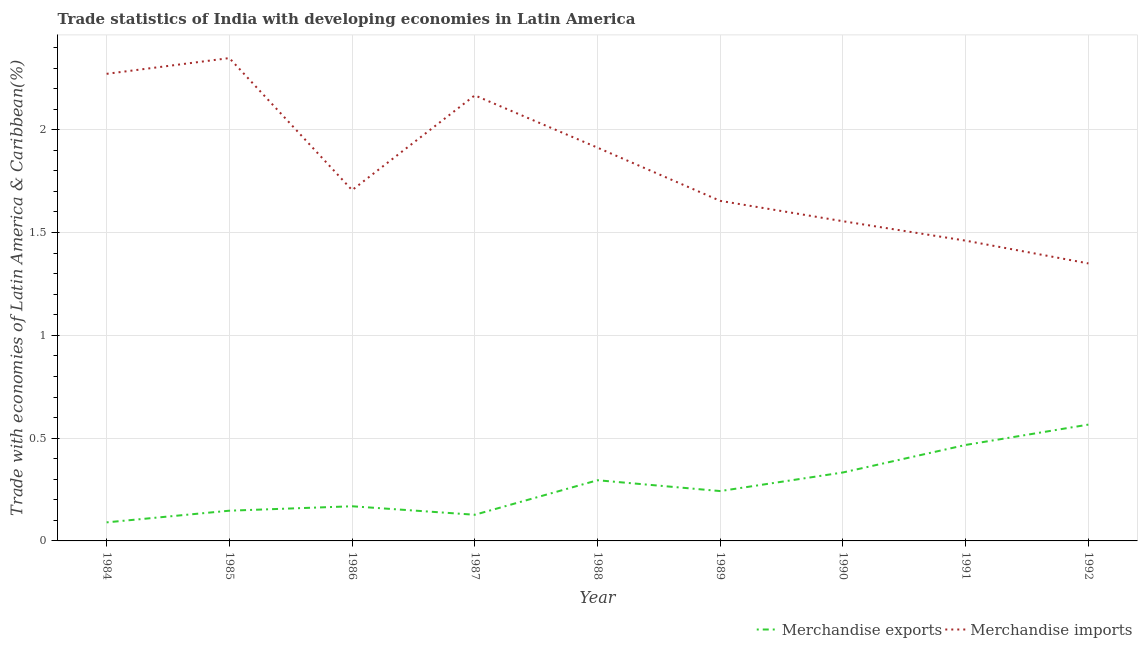Does the line corresponding to merchandise exports intersect with the line corresponding to merchandise imports?
Your answer should be compact. No. Is the number of lines equal to the number of legend labels?
Provide a short and direct response. Yes. What is the merchandise exports in 1989?
Provide a succinct answer. 0.24. Across all years, what is the maximum merchandise imports?
Your response must be concise. 2.35. Across all years, what is the minimum merchandise exports?
Your answer should be very brief. 0.09. In which year was the merchandise imports minimum?
Ensure brevity in your answer.  1992. What is the total merchandise imports in the graph?
Provide a short and direct response. 16.43. What is the difference between the merchandise exports in 1989 and that in 1992?
Your answer should be compact. -0.32. What is the difference between the merchandise imports in 1985 and the merchandise exports in 1990?
Your answer should be very brief. 2.02. What is the average merchandise imports per year?
Provide a succinct answer. 1.83. In the year 1989, what is the difference between the merchandise imports and merchandise exports?
Provide a short and direct response. 1.41. What is the ratio of the merchandise imports in 1984 to that in 1987?
Provide a succinct answer. 1.05. Is the difference between the merchandise imports in 1986 and 1988 greater than the difference between the merchandise exports in 1986 and 1988?
Provide a succinct answer. No. What is the difference between the highest and the second highest merchandise exports?
Offer a very short reply. 0.1. What is the difference between the highest and the lowest merchandise exports?
Offer a very short reply. 0.48. Is the sum of the merchandise imports in 1987 and 1991 greater than the maximum merchandise exports across all years?
Your answer should be very brief. Yes. Does the merchandise imports monotonically increase over the years?
Ensure brevity in your answer.  No. How many lines are there?
Provide a short and direct response. 2. How many years are there in the graph?
Ensure brevity in your answer.  9. What is the difference between two consecutive major ticks on the Y-axis?
Your response must be concise. 0.5. Where does the legend appear in the graph?
Provide a short and direct response. Bottom right. What is the title of the graph?
Your response must be concise. Trade statistics of India with developing economies in Latin America. Does "Rural" appear as one of the legend labels in the graph?
Your response must be concise. No. What is the label or title of the X-axis?
Your answer should be compact. Year. What is the label or title of the Y-axis?
Make the answer very short. Trade with economies of Latin America & Caribbean(%). What is the Trade with economies of Latin America & Caribbean(%) of Merchandise exports in 1984?
Keep it short and to the point. 0.09. What is the Trade with economies of Latin America & Caribbean(%) of Merchandise imports in 1984?
Give a very brief answer. 2.27. What is the Trade with economies of Latin America & Caribbean(%) in Merchandise exports in 1985?
Your answer should be very brief. 0.15. What is the Trade with economies of Latin America & Caribbean(%) in Merchandise imports in 1985?
Your answer should be compact. 2.35. What is the Trade with economies of Latin America & Caribbean(%) in Merchandise exports in 1986?
Ensure brevity in your answer.  0.17. What is the Trade with economies of Latin America & Caribbean(%) in Merchandise imports in 1986?
Give a very brief answer. 1.71. What is the Trade with economies of Latin America & Caribbean(%) of Merchandise exports in 1987?
Make the answer very short. 0.13. What is the Trade with economies of Latin America & Caribbean(%) in Merchandise imports in 1987?
Give a very brief answer. 2.17. What is the Trade with economies of Latin America & Caribbean(%) in Merchandise exports in 1988?
Provide a short and direct response. 0.3. What is the Trade with economies of Latin America & Caribbean(%) in Merchandise imports in 1988?
Your answer should be compact. 1.91. What is the Trade with economies of Latin America & Caribbean(%) in Merchandise exports in 1989?
Your response must be concise. 0.24. What is the Trade with economies of Latin America & Caribbean(%) of Merchandise imports in 1989?
Offer a very short reply. 1.65. What is the Trade with economies of Latin America & Caribbean(%) of Merchandise exports in 1990?
Your answer should be compact. 0.33. What is the Trade with economies of Latin America & Caribbean(%) in Merchandise imports in 1990?
Your response must be concise. 1.56. What is the Trade with economies of Latin America & Caribbean(%) in Merchandise exports in 1991?
Make the answer very short. 0.47. What is the Trade with economies of Latin America & Caribbean(%) of Merchandise imports in 1991?
Keep it short and to the point. 1.46. What is the Trade with economies of Latin America & Caribbean(%) of Merchandise exports in 1992?
Offer a very short reply. 0.57. What is the Trade with economies of Latin America & Caribbean(%) in Merchandise imports in 1992?
Your response must be concise. 1.35. Across all years, what is the maximum Trade with economies of Latin America & Caribbean(%) in Merchandise exports?
Provide a short and direct response. 0.57. Across all years, what is the maximum Trade with economies of Latin America & Caribbean(%) in Merchandise imports?
Provide a succinct answer. 2.35. Across all years, what is the minimum Trade with economies of Latin America & Caribbean(%) of Merchandise exports?
Give a very brief answer. 0.09. Across all years, what is the minimum Trade with economies of Latin America & Caribbean(%) in Merchandise imports?
Your answer should be very brief. 1.35. What is the total Trade with economies of Latin America & Caribbean(%) of Merchandise exports in the graph?
Provide a short and direct response. 2.44. What is the total Trade with economies of Latin America & Caribbean(%) in Merchandise imports in the graph?
Your answer should be very brief. 16.43. What is the difference between the Trade with economies of Latin America & Caribbean(%) in Merchandise exports in 1984 and that in 1985?
Offer a very short reply. -0.06. What is the difference between the Trade with economies of Latin America & Caribbean(%) in Merchandise imports in 1984 and that in 1985?
Offer a very short reply. -0.08. What is the difference between the Trade with economies of Latin America & Caribbean(%) of Merchandise exports in 1984 and that in 1986?
Provide a succinct answer. -0.08. What is the difference between the Trade with economies of Latin America & Caribbean(%) in Merchandise imports in 1984 and that in 1986?
Give a very brief answer. 0.57. What is the difference between the Trade with economies of Latin America & Caribbean(%) in Merchandise exports in 1984 and that in 1987?
Give a very brief answer. -0.04. What is the difference between the Trade with economies of Latin America & Caribbean(%) in Merchandise imports in 1984 and that in 1987?
Offer a terse response. 0.1. What is the difference between the Trade with economies of Latin America & Caribbean(%) of Merchandise exports in 1984 and that in 1988?
Provide a short and direct response. -0.2. What is the difference between the Trade with economies of Latin America & Caribbean(%) of Merchandise imports in 1984 and that in 1988?
Offer a terse response. 0.36. What is the difference between the Trade with economies of Latin America & Caribbean(%) of Merchandise exports in 1984 and that in 1989?
Give a very brief answer. -0.15. What is the difference between the Trade with economies of Latin America & Caribbean(%) of Merchandise imports in 1984 and that in 1989?
Offer a terse response. 0.62. What is the difference between the Trade with economies of Latin America & Caribbean(%) of Merchandise exports in 1984 and that in 1990?
Your response must be concise. -0.24. What is the difference between the Trade with economies of Latin America & Caribbean(%) of Merchandise imports in 1984 and that in 1990?
Provide a succinct answer. 0.72. What is the difference between the Trade with economies of Latin America & Caribbean(%) of Merchandise exports in 1984 and that in 1991?
Keep it short and to the point. -0.38. What is the difference between the Trade with economies of Latin America & Caribbean(%) in Merchandise imports in 1984 and that in 1991?
Your response must be concise. 0.81. What is the difference between the Trade with economies of Latin America & Caribbean(%) in Merchandise exports in 1984 and that in 1992?
Provide a short and direct response. -0.48. What is the difference between the Trade with economies of Latin America & Caribbean(%) in Merchandise imports in 1984 and that in 1992?
Provide a short and direct response. 0.92. What is the difference between the Trade with economies of Latin America & Caribbean(%) of Merchandise exports in 1985 and that in 1986?
Your answer should be compact. -0.02. What is the difference between the Trade with economies of Latin America & Caribbean(%) in Merchandise imports in 1985 and that in 1986?
Keep it short and to the point. 0.64. What is the difference between the Trade with economies of Latin America & Caribbean(%) of Merchandise exports in 1985 and that in 1987?
Make the answer very short. 0.02. What is the difference between the Trade with economies of Latin America & Caribbean(%) in Merchandise imports in 1985 and that in 1987?
Provide a short and direct response. 0.18. What is the difference between the Trade with economies of Latin America & Caribbean(%) in Merchandise exports in 1985 and that in 1988?
Make the answer very short. -0.15. What is the difference between the Trade with economies of Latin America & Caribbean(%) in Merchandise imports in 1985 and that in 1988?
Your response must be concise. 0.44. What is the difference between the Trade with economies of Latin America & Caribbean(%) in Merchandise exports in 1985 and that in 1989?
Provide a short and direct response. -0.1. What is the difference between the Trade with economies of Latin America & Caribbean(%) in Merchandise imports in 1985 and that in 1989?
Provide a succinct answer. 0.69. What is the difference between the Trade with economies of Latin America & Caribbean(%) of Merchandise exports in 1985 and that in 1990?
Your answer should be very brief. -0.19. What is the difference between the Trade with economies of Latin America & Caribbean(%) of Merchandise imports in 1985 and that in 1990?
Your response must be concise. 0.79. What is the difference between the Trade with economies of Latin America & Caribbean(%) of Merchandise exports in 1985 and that in 1991?
Keep it short and to the point. -0.32. What is the difference between the Trade with economies of Latin America & Caribbean(%) in Merchandise imports in 1985 and that in 1991?
Provide a succinct answer. 0.89. What is the difference between the Trade with economies of Latin America & Caribbean(%) of Merchandise exports in 1985 and that in 1992?
Keep it short and to the point. -0.42. What is the difference between the Trade with economies of Latin America & Caribbean(%) in Merchandise exports in 1986 and that in 1987?
Offer a terse response. 0.04. What is the difference between the Trade with economies of Latin America & Caribbean(%) in Merchandise imports in 1986 and that in 1987?
Ensure brevity in your answer.  -0.46. What is the difference between the Trade with economies of Latin America & Caribbean(%) in Merchandise exports in 1986 and that in 1988?
Provide a short and direct response. -0.13. What is the difference between the Trade with economies of Latin America & Caribbean(%) of Merchandise imports in 1986 and that in 1988?
Ensure brevity in your answer.  -0.21. What is the difference between the Trade with economies of Latin America & Caribbean(%) in Merchandise exports in 1986 and that in 1989?
Keep it short and to the point. -0.07. What is the difference between the Trade with economies of Latin America & Caribbean(%) of Merchandise imports in 1986 and that in 1989?
Give a very brief answer. 0.05. What is the difference between the Trade with economies of Latin America & Caribbean(%) in Merchandise exports in 1986 and that in 1990?
Provide a succinct answer. -0.16. What is the difference between the Trade with economies of Latin America & Caribbean(%) in Merchandise imports in 1986 and that in 1990?
Make the answer very short. 0.15. What is the difference between the Trade with economies of Latin America & Caribbean(%) in Merchandise exports in 1986 and that in 1991?
Offer a very short reply. -0.3. What is the difference between the Trade with economies of Latin America & Caribbean(%) of Merchandise imports in 1986 and that in 1991?
Make the answer very short. 0.25. What is the difference between the Trade with economies of Latin America & Caribbean(%) in Merchandise exports in 1986 and that in 1992?
Ensure brevity in your answer.  -0.4. What is the difference between the Trade with economies of Latin America & Caribbean(%) in Merchandise imports in 1986 and that in 1992?
Your answer should be very brief. 0.36. What is the difference between the Trade with economies of Latin America & Caribbean(%) in Merchandise exports in 1987 and that in 1988?
Ensure brevity in your answer.  -0.17. What is the difference between the Trade with economies of Latin America & Caribbean(%) of Merchandise imports in 1987 and that in 1988?
Offer a very short reply. 0.25. What is the difference between the Trade with economies of Latin America & Caribbean(%) in Merchandise exports in 1987 and that in 1989?
Make the answer very short. -0.12. What is the difference between the Trade with economies of Latin America & Caribbean(%) in Merchandise imports in 1987 and that in 1989?
Keep it short and to the point. 0.51. What is the difference between the Trade with economies of Latin America & Caribbean(%) of Merchandise exports in 1987 and that in 1990?
Your answer should be compact. -0.21. What is the difference between the Trade with economies of Latin America & Caribbean(%) of Merchandise imports in 1987 and that in 1990?
Offer a very short reply. 0.61. What is the difference between the Trade with economies of Latin America & Caribbean(%) of Merchandise exports in 1987 and that in 1991?
Give a very brief answer. -0.34. What is the difference between the Trade with economies of Latin America & Caribbean(%) in Merchandise imports in 1987 and that in 1991?
Offer a very short reply. 0.71. What is the difference between the Trade with economies of Latin America & Caribbean(%) of Merchandise exports in 1987 and that in 1992?
Make the answer very short. -0.44. What is the difference between the Trade with economies of Latin America & Caribbean(%) in Merchandise imports in 1987 and that in 1992?
Offer a terse response. 0.82. What is the difference between the Trade with economies of Latin America & Caribbean(%) of Merchandise exports in 1988 and that in 1989?
Your answer should be compact. 0.05. What is the difference between the Trade with economies of Latin America & Caribbean(%) in Merchandise imports in 1988 and that in 1989?
Your answer should be compact. 0.26. What is the difference between the Trade with economies of Latin America & Caribbean(%) of Merchandise exports in 1988 and that in 1990?
Ensure brevity in your answer.  -0.04. What is the difference between the Trade with economies of Latin America & Caribbean(%) of Merchandise imports in 1988 and that in 1990?
Provide a short and direct response. 0.36. What is the difference between the Trade with economies of Latin America & Caribbean(%) in Merchandise exports in 1988 and that in 1991?
Give a very brief answer. -0.17. What is the difference between the Trade with economies of Latin America & Caribbean(%) of Merchandise imports in 1988 and that in 1991?
Ensure brevity in your answer.  0.45. What is the difference between the Trade with economies of Latin America & Caribbean(%) of Merchandise exports in 1988 and that in 1992?
Ensure brevity in your answer.  -0.27. What is the difference between the Trade with economies of Latin America & Caribbean(%) of Merchandise imports in 1988 and that in 1992?
Give a very brief answer. 0.56. What is the difference between the Trade with economies of Latin America & Caribbean(%) in Merchandise exports in 1989 and that in 1990?
Offer a very short reply. -0.09. What is the difference between the Trade with economies of Latin America & Caribbean(%) in Merchandise imports in 1989 and that in 1990?
Offer a very short reply. 0.1. What is the difference between the Trade with economies of Latin America & Caribbean(%) of Merchandise exports in 1989 and that in 1991?
Your answer should be compact. -0.22. What is the difference between the Trade with economies of Latin America & Caribbean(%) of Merchandise imports in 1989 and that in 1991?
Give a very brief answer. 0.19. What is the difference between the Trade with economies of Latin America & Caribbean(%) of Merchandise exports in 1989 and that in 1992?
Provide a short and direct response. -0.32. What is the difference between the Trade with economies of Latin America & Caribbean(%) of Merchandise imports in 1989 and that in 1992?
Give a very brief answer. 0.3. What is the difference between the Trade with economies of Latin America & Caribbean(%) in Merchandise exports in 1990 and that in 1991?
Provide a succinct answer. -0.13. What is the difference between the Trade with economies of Latin America & Caribbean(%) of Merchandise imports in 1990 and that in 1991?
Make the answer very short. 0.09. What is the difference between the Trade with economies of Latin America & Caribbean(%) of Merchandise exports in 1990 and that in 1992?
Give a very brief answer. -0.23. What is the difference between the Trade with economies of Latin America & Caribbean(%) of Merchandise imports in 1990 and that in 1992?
Provide a short and direct response. 0.21. What is the difference between the Trade with economies of Latin America & Caribbean(%) of Merchandise exports in 1991 and that in 1992?
Ensure brevity in your answer.  -0.1. What is the difference between the Trade with economies of Latin America & Caribbean(%) in Merchandise imports in 1991 and that in 1992?
Your answer should be compact. 0.11. What is the difference between the Trade with economies of Latin America & Caribbean(%) of Merchandise exports in 1984 and the Trade with economies of Latin America & Caribbean(%) of Merchandise imports in 1985?
Your answer should be compact. -2.26. What is the difference between the Trade with economies of Latin America & Caribbean(%) of Merchandise exports in 1984 and the Trade with economies of Latin America & Caribbean(%) of Merchandise imports in 1986?
Make the answer very short. -1.62. What is the difference between the Trade with economies of Latin America & Caribbean(%) of Merchandise exports in 1984 and the Trade with economies of Latin America & Caribbean(%) of Merchandise imports in 1987?
Provide a short and direct response. -2.08. What is the difference between the Trade with economies of Latin America & Caribbean(%) of Merchandise exports in 1984 and the Trade with economies of Latin America & Caribbean(%) of Merchandise imports in 1988?
Keep it short and to the point. -1.82. What is the difference between the Trade with economies of Latin America & Caribbean(%) in Merchandise exports in 1984 and the Trade with economies of Latin America & Caribbean(%) in Merchandise imports in 1989?
Your response must be concise. -1.56. What is the difference between the Trade with economies of Latin America & Caribbean(%) in Merchandise exports in 1984 and the Trade with economies of Latin America & Caribbean(%) in Merchandise imports in 1990?
Your answer should be compact. -1.46. What is the difference between the Trade with economies of Latin America & Caribbean(%) of Merchandise exports in 1984 and the Trade with economies of Latin America & Caribbean(%) of Merchandise imports in 1991?
Make the answer very short. -1.37. What is the difference between the Trade with economies of Latin America & Caribbean(%) in Merchandise exports in 1984 and the Trade with economies of Latin America & Caribbean(%) in Merchandise imports in 1992?
Provide a succinct answer. -1.26. What is the difference between the Trade with economies of Latin America & Caribbean(%) in Merchandise exports in 1985 and the Trade with economies of Latin America & Caribbean(%) in Merchandise imports in 1986?
Your answer should be very brief. -1.56. What is the difference between the Trade with economies of Latin America & Caribbean(%) in Merchandise exports in 1985 and the Trade with economies of Latin America & Caribbean(%) in Merchandise imports in 1987?
Offer a very short reply. -2.02. What is the difference between the Trade with economies of Latin America & Caribbean(%) in Merchandise exports in 1985 and the Trade with economies of Latin America & Caribbean(%) in Merchandise imports in 1988?
Provide a short and direct response. -1.77. What is the difference between the Trade with economies of Latin America & Caribbean(%) of Merchandise exports in 1985 and the Trade with economies of Latin America & Caribbean(%) of Merchandise imports in 1989?
Provide a succinct answer. -1.51. What is the difference between the Trade with economies of Latin America & Caribbean(%) in Merchandise exports in 1985 and the Trade with economies of Latin America & Caribbean(%) in Merchandise imports in 1990?
Make the answer very short. -1.41. What is the difference between the Trade with economies of Latin America & Caribbean(%) in Merchandise exports in 1985 and the Trade with economies of Latin America & Caribbean(%) in Merchandise imports in 1991?
Provide a short and direct response. -1.31. What is the difference between the Trade with economies of Latin America & Caribbean(%) in Merchandise exports in 1985 and the Trade with economies of Latin America & Caribbean(%) in Merchandise imports in 1992?
Make the answer very short. -1.2. What is the difference between the Trade with economies of Latin America & Caribbean(%) of Merchandise exports in 1986 and the Trade with economies of Latin America & Caribbean(%) of Merchandise imports in 1987?
Ensure brevity in your answer.  -2. What is the difference between the Trade with economies of Latin America & Caribbean(%) of Merchandise exports in 1986 and the Trade with economies of Latin America & Caribbean(%) of Merchandise imports in 1988?
Provide a short and direct response. -1.74. What is the difference between the Trade with economies of Latin America & Caribbean(%) of Merchandise exports in 1986 and the Trade with economies of Latin America & Caribbean(%) of Merchandise imports in 1989?
Your answer should be very brief. -1.49. What is the difference between the Trade with economies of Latin America & Caribbean(%) of Merchandise exports in 1986 and the Trade with economies of Latin America & Caribbean(%) of Merchandise imports in 1990?
Offer a terse response. -1.39. What is the difference between the Trade with economies of Latin America & Caribbean(%) of Merchandise exports in 1986 and the Trade with economies of Latin America & Caribbean(%) of Merchandise imports in 1991?
Your response must be concise. -1.29. What is the difference between the Trade with economies of Latin America & Caribbean(%) of Merchandise exports in 1986 and the Trade with economies of Latin America & Caribbean(%) of Merchandise imports in 1992?
Give a very brief answer. -1.18. What is the difference between the Trade with economies of Latin America & Caribbean(%) in Merchandise exports in 1987 and the Trade with economies of Latin America & Caribbean(%) in Merchandise imports in 1988?
Give a very brief answer. -1.79. What is the difference between the Trade with economies of Latin America & Caribbean(%) of Merchandise exports in 1987 and the Trade with economies of Latin America & Caribbean(%) of Merchandise imports in 1989?
Ensure brevity in your answer.  -1.53. What is the difference between the Trade with economies of Latin America & Caribbean(%) of Merchandise exports in 1987 and the Trade with economies of Latin America & Caribbean(%) of Merchandise imports in 1990?
Provide a succinct answer. -1.43. What is the difference between the Trade with economies of Latin America & Caribbean(%) of Merchandise exports in 1987 and the Trade with economies of Latin America & Caribbean(%) of Merchandise imports in 1991?
Your response must be concise. -1.33. What is the difference between the Trade with economies of Latin America & Caribbean(%) in Merchandise exports in 1987 and the Trade with economies of Latin America & Caribbean(%) in Merchandise imports in 1992?
Keep it short and to the point. -1.22. What is the difference between the Trade with economies of Latin America & Caribbean(%) of Merchandise exports in 1988 and the Trade with economies of Latin America & Caribbean(%) of Merchandise imports in 1989?
Ensure brevity in your answer.  -1.36. What is the difference between the Trade with economies of Latin America & Caribbean(%) of Merchandise exports in 1988 and the Trade with economies of Latin America & Caribbean(%) of Merchandise imports in 1990?
Ensure brevity in your answer.  -1.26. What is the difference between the Trade with economies of Latin America & Caribbean(%) in Merchandise exports in 1988 and the Trade with economies of Latin America & Caribbean(%) in Merchandise imports in 1991?
Provide a succinct answer. -1.17. What is the difference between the Trade with economies of Latin America & Caribbean(%) of Merchandise exports in 1988 and the Trade with economies of Latin America & Caribbean(%) of Merchandise imports in 1992?
Offer a terse response. -1.05. What is the difference between the Trade with economies of Latin America & Caribbean(%) in Merchandise exports in 1989 and the Trade with economies of Latin America & Caribbean(%) in Merchandise imports in 1990?
Make the answer very short. -1.31. What is the difference between the Trade with economies of Latin America & Caribbean(%) in Merchandise exports in 1989 and the Trade with economies of Latin America & Caribbean(%) in Merchandise imports in 1991?
Provide a short and direct response. -1.22. What is the difference between the Trade with economies of Latin America & Caribbean(%) of Merchandise exports in 1989 and the Trade with economies of Latin America & Caribbean(%) of Merchandise imports in 1992?
Make the answer very short. -1.11. What is the difference between the Trade with economies of Latin America & Caribbean(%) of Merchandise exports in 1990 and the Trade with economies of Latin America & Caribbean(%) of Merchandise imports in 1991?
Provide a short and direct response. -1.13. What is the difference between the Trade with economies of Latin America & Caribbean(%) in Merchandise exports in 1990 and the Trade with economies of Latin America & Caribbean(%) in Merchandise imports in 1992?
Keep it short and to the point. -1.02. What is the difference between the Trade with economies of Latin America & Caribbean(%) in Merchandise exports in 1991 and the Trade with economies of Latin America & Caribbean(%) in Merchandise imports in 1992?
Ensure brevity in your answer.  -0.88. What is the average Trade with economies of Latin America & Caribbean(%) of Merchandise exports per year?
Your answer should be very brief. 0.27. What is the average Trade with economies of Latin America & Caribbean(%) of Merchandise imports per year?
Ensure brevity in your answer.  1.83. In the year 1984, what is the difference between the Trade with economies of Latin America & Caribbean(%) of Merchandise exports and Trade with economies of Latin America & Caribbean(%) of Merchandise imports?
Give a very brief answer. -2.18. In the year 1985, what is the difference between the Trade with economies of Latin America & Caribbean(%) in Merchandise exports and Trade with economies of Latin America & Caribbean(%) in Merchandise imports?
Offer a very short reply. -2.2. In the year 1986, what is the difference between the Trade with economies of Latin America & Caribbean(%) in Merchandise exports and Trade with economies of Latin America & Caribbean(%) in Merchandise imports?
Offer a very short reply. -1.54. In the year 1987, what is the difference between the Trade with economies of Latin America & Caribbean(%) in Merchandise exports and Trade with economies of Latin America & Caribbean(%) in Merchandise imports?
Provide a succinct answer. -2.04. In the year 1988, what is the difference between the Trade with economies of Latin America & Caribbean(%) of Merchandise exports and Trade with economies of Latin America & Caribbean(%) of Merchandise imports?
Provide a succinct answer. -1.62. In the year 1989, what is the difference between the Trade with economies of Latin America & Caribbean(%) in Merchandise exports and Trade with economies of Latin America & Caribbean(%) in Merchandise imports?
Keep it short and to the point. -1.41. In the year 1990, what is the difference between the Trade with economies of Latin America & Caribbean(%) in Merchandise exports and Trade with economies of Latin America & Caribbean(%) in Merchandise imports?
Offer a terse response. -1.22. In the year 1991, what is the difference between the Trade with economies of Latin America & Caribbean(%) of Merchandise exports and Trade with economies of Latin America & Caribbean(%) of Merchandise imports?
Ensure brevity in your answer.  -0.99. In the year 1992, what is the difference between the Trade with economies of Latin America & Caribbean(%) of Merchandise exports and Trade with economies of Latin America & Caribbean(%) of Merchandise imports?
Provide a short and direct response. -0.78. What is the ratio of the Trade with economies of Latin America & Caribbean(%) of Merchandise exports in 1984 to that in 1985?
Make the answer very short. 0.61. What is the ratio of the Trade with economies of Latin America & Caribbean(%) in Merchandise imports in 1984 to that in 1985?
Offer a terse response. 0.97. What is the ratio of the Trade with economies of Latin America & Caribbean(%) of Merchandise exports in 1984 to that in 1986?
Your response must be concise. 0.54. What is the ratio of the Trade with economies of Latin America & Caribbean(%) of Merchandise imports in 1984 to that in 1986?
Give a very brief answer. 1.33. What is the ratio of the Trade with economies of Latin America & Caribbean(%) in Merchandise exports in 1984 to that in 1987?
Your response must be concise. 0.71. What is the ratio of the Trade with economies of Latin America & Caribbean(%) in Merchandise imports in 1984 to that in 1987?
Your response must be concise. 1.05. What is the ratio of the Trade with economies of Latin America & Caribbean(%) in Merchandise exports in 1984 to that in 1988?
Offer a terse response. 0.31. What is the ratio of the Trade with economies of Latin America & Caribbean(%) in Merchandise imports in 1984 to that in 1988?
Provide a short and direct response. 1.19. What is the ratio of the Trade with economies of Latin America & Caribbean(%) in Merchandise exports in 1984 to that in 1989?
Your answer should be very brief. 0.37. What is the ratio of the Trade with economies of Latin America & Caribbean(%) of Merchandise imports in 1984 to that in 1989?
Your answer should be compact. 1.37. What is the ratio of the Trade with economies of Latin America & Caribbean(%) in Merchandise exports in 1984 to that in 1990?
Provide a short and direct response. 0.27. What is the ratio of the Trade with economies of Latin America & Caribbean(%) of Merchandise imports in 1984 to that in 1990?
Your response must be concise. 1.46. What is the ratio of the Trade with economies of Latin America & Caribbean(%) of Merchandise exports in 1984 to that in 1991?
Provide a short and direct response. 0.19. What is the ratio of the Trade with economies of Latin America & Caribbean(%) in Merchandise imports in 1984 to that in 1991?
Give a very brief answer. 1.56. What is the ratio of the Trade with economies of Latin America & Caribbean(%) in Merchandise exports in 1984 to that in 1992?
Your answer should be very brief. 0.16. What is the ratio of the Trade with economies of Latin America & Caribbean(%) of Merchandise imports in 1984 to that in 1992?
Your answer should be compact. 1.68. What is the ratio of the Trade with economies of Latin America & Caribbean(%) of Merchandise exports in 1985 to that in 1986?
Provide a short and direct response. 0.87. What is the ratio of the Trade with economies of Latin America & Caribbean(%) of Merchandise imports in 1985 to that in 1986?
Provide a short and direct response. 1.38. What is the ratio of the Trade with economies of Latin America & Caribbean(%) of Merchandise exports in 1985 to that in 1987?
Provide a succinct answer. 1.16. What is the ratio of the Trade with economies of Latin America & Caribbean(%) of Merchandise imports in 1985 to that in 1987?
Your answer should be very brief. 1.08. What is the ratio of the Trade with economies of Latin America & Caribbean(%) of Merchandise exports in 1985 to that in 1988?
Ensure brevity in your answer.  0.5. What is the ratio of the Trade with economies of Latin America & Caribbean(%) in Merchandise imports in 1985 to that in 1988?
Your answer should be very brief. 1.23. What is the ratio of the Trade with economies of Latin America & Caribbean(%) of Merchandise exports in 1985 to that in 1989?
Your answer should be very brief. 0.61. What is the ratio of the Trade with economies of Latin America & Caribbean(%) of Merchandise imports in 1985 to that in 1989?
Offer a terse response. 1.42. What is the ratio of the Trade with economies of Latin America & Caribbean(%) of Merchandise exports in 1985 to that in 1990?
Provide a succinct answer. 0.44. What is the ratio of the Trade with economies of Latin America & Caribbean(%) of Merchandise imports in 1985 to that in 1990?
Provide a succinct answer. 1.51. What is the ratio of the Trade with economies of Latin America & Caribbean(%) of Merchandise exports in 1985 to that in 1991?
Offer a very short reply. 0.31. What is the ratio of the Trade with economies of Latin America & Caribbean(%) in Merchandise imports in 1985 to that in 1991?
Provide a succinct answer. 1.61. What is the ratio of the Trade with economies of Latin America & Caribbean(%) of Merchandise exports in 1985 to that in 1992?
Make the answer very short. 0.26. What is the ratio of the Trade with economies of Latin America & Caribbean(%) of Merchandise imports in 1985 to that in 1992?
Your answer should be compact. 1.74. What is the ratio of the Trade with economies of Latin America & Caribbean(%) of Merchandise exports in 1986 to that in 1987?
Offer a terse response. 1.32. What is the ratio of the Trade with economies of Latin America & Caribbean(%) of Merchandise imports in 1986 to that in 1987?
Your answer should be compact. 0.79. What is the ratio of the Trade with economies of Latin America & Caribbean(%) in Merchandise exports in 1986 to that in 1988?
Offer a very short reply. 0.57. What is the ratio of the Trade with economies of Latin America & Caribbean(%) of Merchandise imports in 1986 to that in 1988?
Provide a short and direct response. 0.89. What is the ratio of the Trade with economies of Latin America & Caribbean(%) of Merchandise exports in 1986 to that in 1989?
Provide a short and direct response. 0.7. What is the ratio of the Trade with economies of Latin America & Caribbean(%) of Merchandise imports in 1986 to that in 1989?
Your response must be concise. 1.03. What is the ratio of the Trade with economies of Latin America & Caribbean(%) in Merchandise exports in 1986 to that in 1990?
Ensure brevity in your answer.  0.51. What is the ratio of the Trade with economies of Latin America & Caribbean(%) of Merchandise imports in 1986 to that in 1990?
Keep it short and to the point. 1.1. What is the ratio of the Trade with economies of Latin America & Caribbean(%) of Merchandise exports in 1986 to that in 1991?
Your response must be concise. 0.36. What is the ratio of the Trade with economies of Latin America & Caribbean(%) in Merchandise imports in 1986 to that in 1991?
Offer a very short reply. 1.17. What is the ratio of the Trade with economies of Latin America & Caribbean(%) of Merchandise exports in 1986 to that in 1992?
Make the answer very short. 0.3. What is the ratio of the Trade with economies of Latin America & Caribbean(%) of Merchandise imports in 1986 to that in 1992?
Provide a short and direct response. 1.26. What is the ratio of the Trade with economies of Latin America & Caribbean(%) in Merchandise exports in 1987 to that in 1988?
Your answer should be very brief. 0.43. What is the ratio of the Trade with economies of Latin America & Caribbean(%) in Merchandise imports in 1987 to that in 1988?
Provide a succinct answer. 1.13. What is the ratio of the Trade with economies of Latin America & Caribbean(%) of Merchandise exports in 1987 to that in 1989?
Ensure brevity in your answer.  0.52. What is the ratio of the Trade with economies of Latin America & Caribbean(%) in Merchandise imports in 1987 to that in 1989?
Ensure brevity in your answer.  1.31. What is the ratio of the Trade with economies of Latin America & Caribbean(%) in Merchandise exports in 1987 to that in 1990?
Give a very brief answer. 0.38. What is the ratio of the Trade with economies of Latin America & Caribbean(%) in Merchandise imports in 1987 to that in 1990?
Your answer should be compact. 1.39. What is the ratio of the Trade with economies of Latin America & Caribbean(%) of Merchandise exports in 1987 to that in 1991?
Keep it short and to the point. 0.27. What is the ratio of the Trade with economies of Latin America & Caribbean(%) of Merchandise imports in 1987 to that in 1991?
Your response must be concise. 1.48. What is the ratio of the Trade with economies of Latin America & Caribbean(%) in Merchandise exports in 1987 to that in 1992?
Offer a terse response. 0.22. What is the ratio of the Trade with economies of Latin America & Caribbean(%) in Merchandise imports in 1987 to that in 1992?
Give a very brief answer. 1.61. What is the ratio of the Trade with economies of Latin America & Caribbean(%) of Merchandise exports in 1988 to that in 1989?
Your answer should be very brief. 1.22. What is the ratio of the Trade with economies of Latin America & Caribbean(%) in Merchandise imports in 1988 to that in 1989?
Make the answer very short. 1.16. What is the ratio of the Trade with economies of Latin America & Caribbean(%) of Merchandise exports in 1988 to that in 1990?
Make the answer very short. 0.89. What is the ratio of the Trade with economies of Latin America & Caribbean(%) in Merchandise imports in 1988 to that in 1990?
Provide a short and direct response. 1.23. What is the ratio of the Trade with economies of Latin America & Caribbean(%) of Merchandise exports in 1988 to that in 1991?
Offer a terse response. 0.63. What is the ratio of the Trade with economies of Latin America & Caribbean(%) of Merchandise imports in 1988 to that in 1991?
Keep it short and to the point. 1.31. What is the ratio of the Trade with economies of Latin America & Caribbean(%) in Merchandise exports in 1988 to that in 1992?
Your response must be concise. 0.52. What is the ratio of the Trade with economies of Latin America & Caribbean(%) of Merchandise imports in 1988 to that in 1992?
Provide a short and direct response. 1.42. What is the ratio of the Trade with economies of Latin America & Caribbean(%) in Merchandise exports in 1989 to that in 1990?
Keep it short and to the point. 0.73. What is the ratio of the Trade with economies of Latin America & Caribbean(%) in Merchandise imports in 1989 to that in 1990?
Your answer should be very brief. 1.06. What is the ratio of the Trade with economies of Latin America & Caribbean(%) in Merchandise exports in 1989 to that in 1991?
Provide a succinct answer. 0.52. What is the ratio of the Trade with economies of Latin America & Caribbean(%) in Merchandise imports in 1989 to that in 1991?
Offer a very short reply. 1.13. What is the ratio of the Trade with economies of Latin America & Caribbean(%) in Merchandise exports in 1989 to that in 1992?
Offer a terse response. 0.43. What is the ratio of the Trade with economies of Latin America & Caribbean(%) of Merchandise imports in 1989 to that in 1992?
Offer a terse response. 1.23. What is the ratio of the Trade with economies of Latin America & Caribbean(%) in Merchandise exports in 1990 to that in 1991?
Your response must be concise. 0.71. What is the ratio of the Trade with economies of Latin America & Caribbean(%) of Merchandise imports in 1990 to that in 1991?
Keep it short and to the point. 1.06. What is the ratio of the Trade with economies of Latin America & Caribbean(%) of Merchandise exports in 1990 to that in 1992?
Make the answer very short. 0.59. What is the ratio of the Trade with economies of Latin America & Caribbean(%) of Merchandise imports in 1990 to that in 1992?
Offer a very short reply. 1.15. What is the ratio of the Trade with economies of Latin America & Caribbean(%) in Merchandise exports in 1991 to that in 1992?
Make the answer very short. 0.83. What is the ratio of the Trade with economies of Latin America & Caribbean(%) of Merchandise imports in 1991 to that in 1992?
Make the answer very short. 1.08. What is the difference between the highest and the second highest Trade with economies of Latin America & Caribbean(%) of Merchandise exports?
Ensure brevity in your answer.  0.1. What is the difference between the highest and the second highest Trade with economies of Latin America & Caribbean(%) in Merchandise imports?
Your answer should be compact. 0.08. What is the difference between the highest and the lowest Trade with economies of Latin America & Caribbean(%) in Merchandise exports?
Make the answer very short. 0.48. 